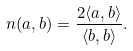<formula> <loc_0><loc_0><loc_500><loc_500>n ( a , b ) = \frac { 2 \langle a , b \rangle } { \langle b , b \rangle } .</formula> 